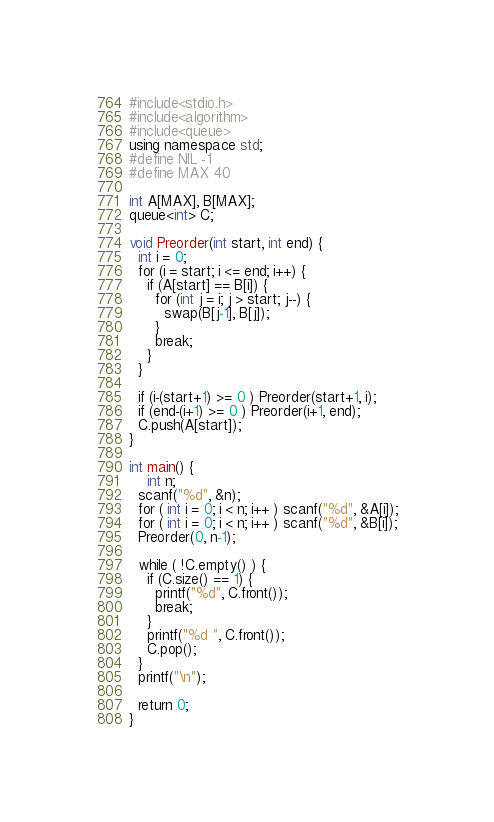<code> <loc_0><loc_0><loc_500><loc_500><_C++_>#include<stdio.h>
#include<algorithm>
#include<queue>
using namespace std;
#define NIL -1
#define MAX 40

int A[MAX], B[MAX];
queue<int> C;

void Preorder(int start, int end) {
  int i = 0;
  for (i = start; i <= end; i++) {
    if (A[start] == B[i]) {
      for (int j = i; j > start; j--) {
        swap(B[j-1], B[j]);
      }
      break;
    }
  }

  if (i-(start+1) >= 0 ) Preorder(start+1, i);
  if (end-(i+1) >= 0 ) Preorder(i+1, end);
  C.push(A[start]);
}

int main() {
	int n;
  scanf("%d", &n);
  for ( int i = 0; i < n; i++ ) scanf("%d", &A[i]);
  for ( int i = 0; i < n; i++ ) scanf("%d", &B[i]);
  Preorder(0, n-1);

  while ( !C.empty() ) {
    if (C.size() == 1) {
      printf("%d", C.front());
      break;
    }
    printf("%d ", C.front());
    C.pop();
  }
  printf("\n");

  return 0;
}

</code> 